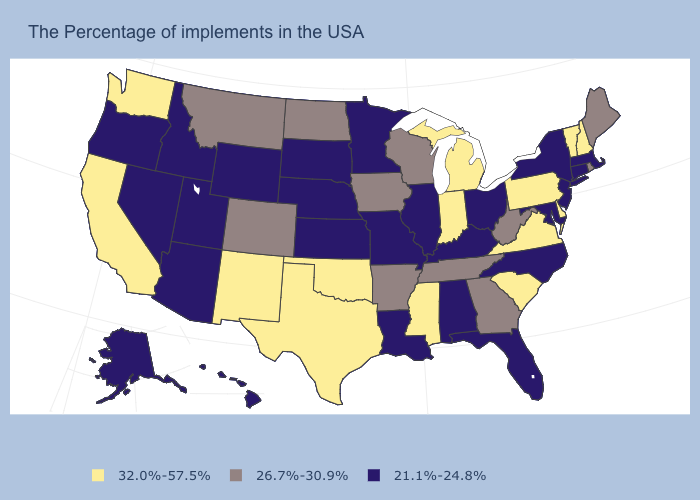Name the states that have a value in the range 32.0%-57.5%?
Quick response, please. New Hampshire, Vermont, Delaware, Pennsylvania, Virginia, South Carolina, Michigan, Indiana, Mississippi, Oklahoma, Texas, New Mexico, California, Washington. Which states have the highest value in the USA?
Quick response, please. New Hampshire, Vermont, Delaware, Pennsylvania, Virginia, South Carolina, Michigan, Indiana, Mississippi, Oklahoma, Texas, New Mexico, California, Washington. Which states have the lowest value in the USA?
Answer briefly. Massachusetts, Connecticut, New York, New Jersey, Maryland, North Carolina, Ohio, Florida, Kentucky, Alabama, Illinois, Louisiana, Missouri, Minnesota, Kansas, Nebraska, South Dakota, Wyoming, Utah, Arizona, Idaho, Nevada, Oregon, Alaska, Hawaii. What is the value of Florida?
Concise answer only. 21.1%-24.8%. Name the states that have a value in the range 32.0%-57.5%?
Be succinct. New Hampshire, Vermont, Delaware, Pennsylvania, Virginia, South Carolina, Michigan, Indiana, Mississippi, Oklahoma, Texas, New Mexico, California, Washington. What is the value of Hawaii?
Quick response, please. 21.1%-24.8%. Which states hav the highest value in the South?
Write a very short answer. Delaware, Virginia, South Carolina, Mississippi, Oklahoma, Texas. What is the highest value in the USA?
Give a very brief answer. 32.0%-57.5%. What is the value of Kansas?
Concise answer only. 21.1%-24.8%. What is the value of Wyoming?
Quick response, please. 21.1%-24.8%. What is the lowest value in states that border Colorado?
Write a very short answer. 21.1%-24.8%. Name the states that have a value in the range 32.0%-57.5%?
Be succinct. New Hampshire, Vermont, Delaware, Pennsylvania, Virginia, South Carolina, Michigan, Indiana, Mississippi, Oklahoma, Texas, New Mexico, California, Washington. Among the states that border Illinois , does Indiana have the highest value?
Concise answer only. Yes. Does Nebraska have a lower value than North Carolina?
Quick response, please. No. Does New York have the lowest value in the USA?
Write a very short answer. Yes. 